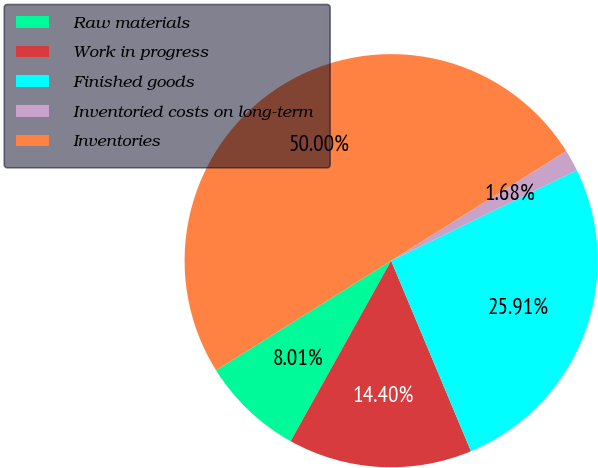Convert chart. <chart><loc_0><loc_0><loc_500><loc_500><pie_chart><fcel>Raw materials<fcel>Work in progress<fcel>Finished goods<fcel>Inventoried costs on long-term<fcel>Inventories<nl><fcel>8.01%<fcel>14.4%<fcel>25.91%<fcel>1.68%<fcel>50.0%<nl></chart> 